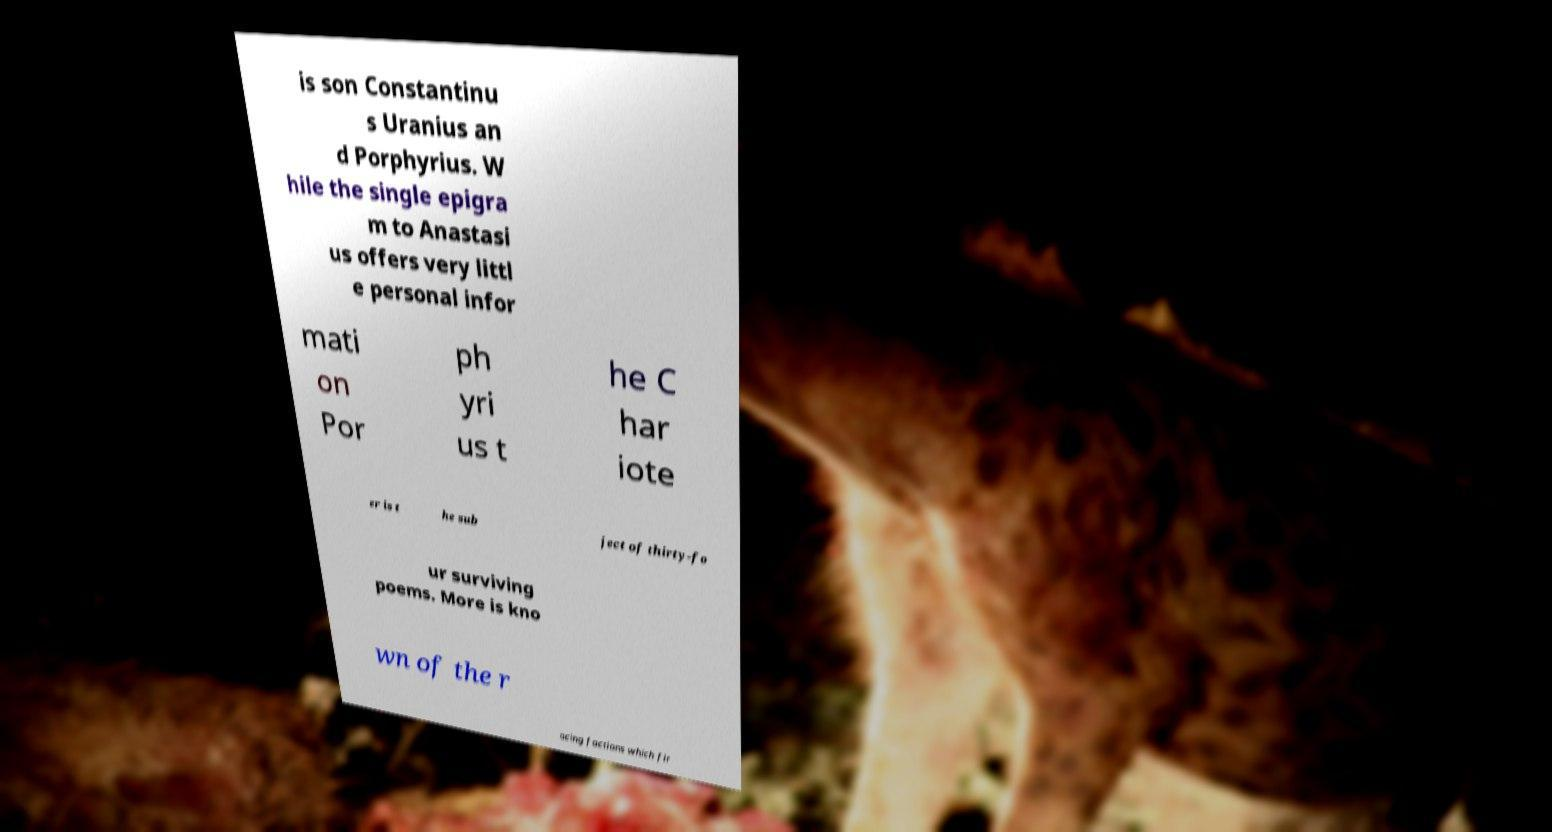Please identify and transcribe the text found in this image. is son Constantinu s Uranius an d Porphyrius. W hile the single epigra m to Anastasi us offers very littl e personal infor mati on Por ph yri us t he C har iote er is t he sub ject of thirty-fo ur surviving poems. More is kno wn of the r acing factions which fir 